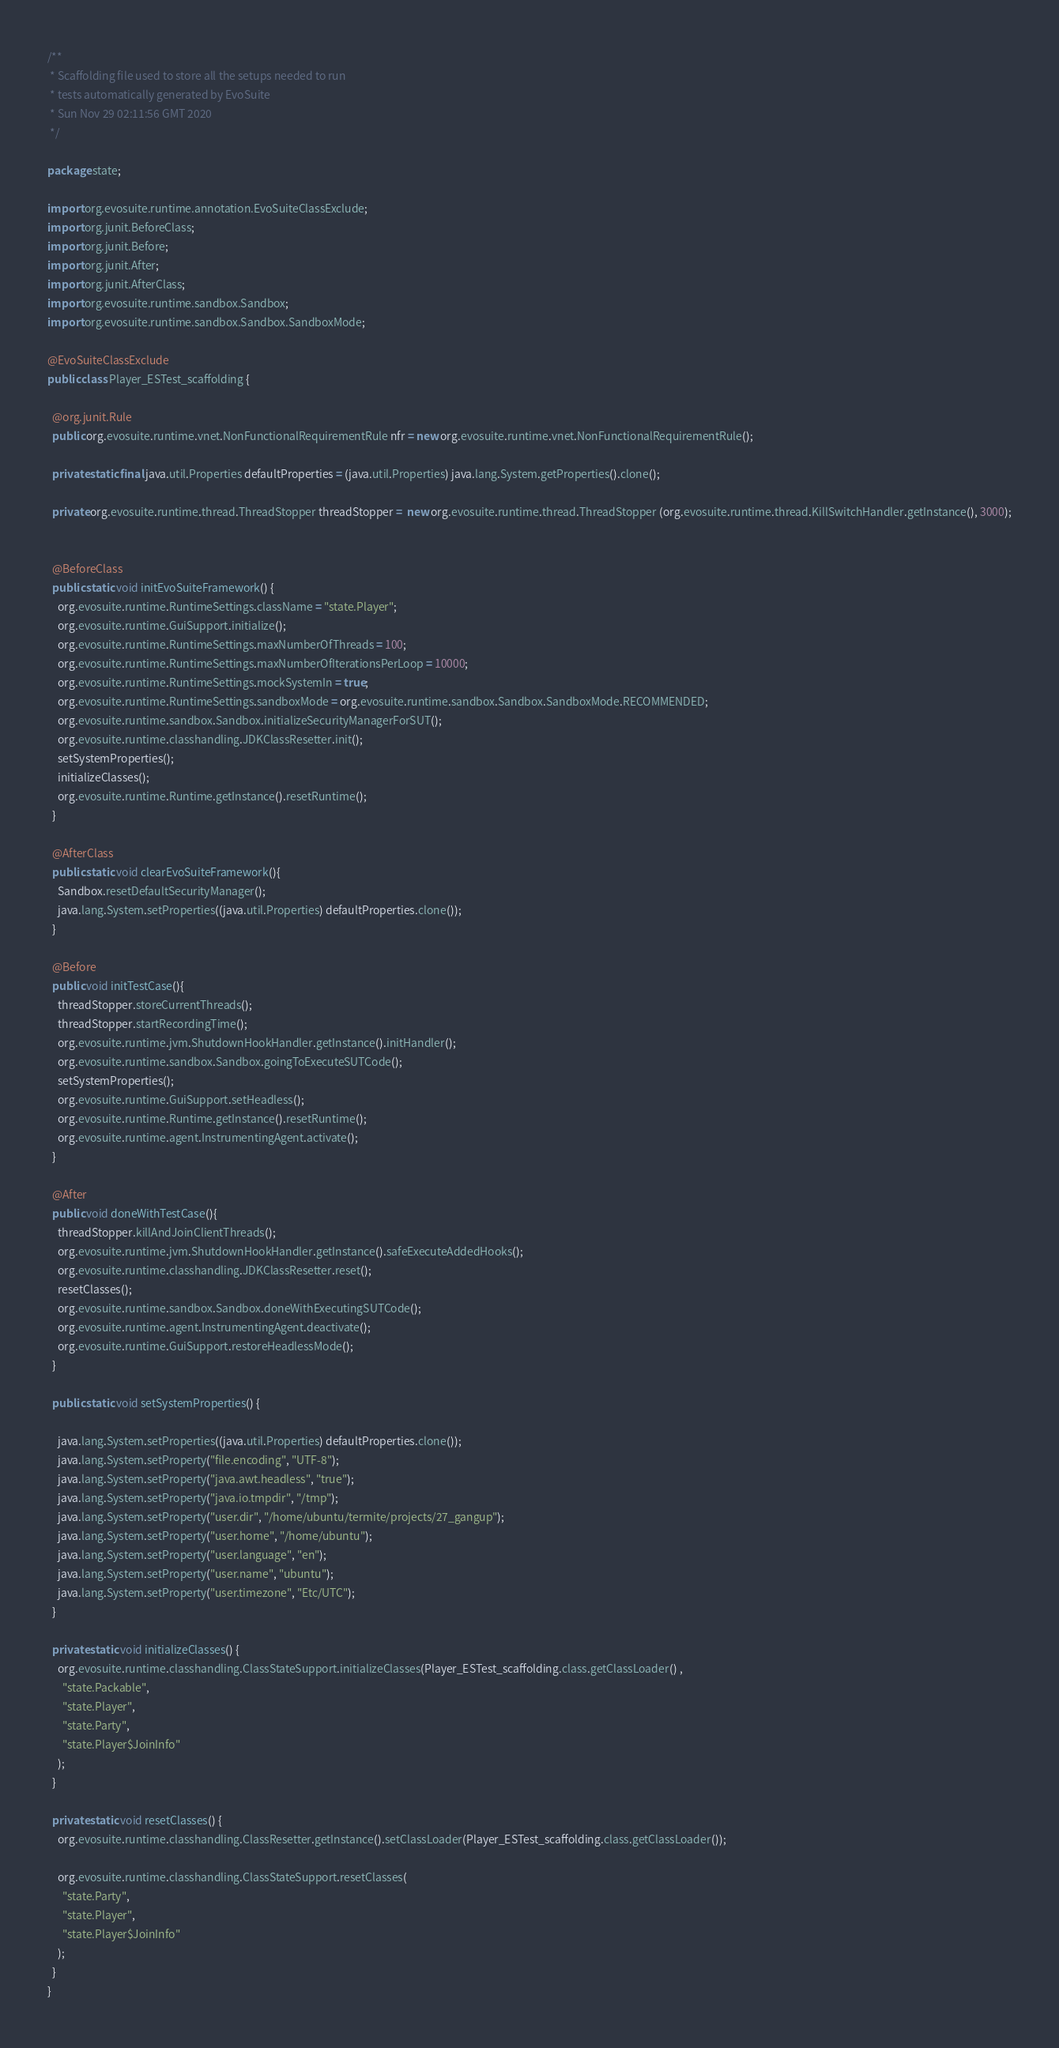Convert code to text. <code><loc_0><loc_0><loc_500><loc_500><_Java_>/**
 * Scaffolding file used to store all the setups needed to run 
 * tests automatically generated by EvoSuite
 * Sun Nov 29 02:11:56 GMT 2020
 */

package state;

import org.evosuite.runtime.annotation.EvoSuiteClassExclude;
import org.junit.BeforeClass;
import org.junit.Before;
import org.junit.After;
import org.junit.AfterClass;
import org.evosuite.runtime.sandbox.Sandbox;
import org.evosuite.runtime.sandbox.Sandbox.SandboxMode;

@EvoSuiteClassExclude
public class Player_ESTest_scaffolding {

  @org.junit.Rule 
  public org.evosuite.runtime.vnet.NonFunctionalRequirementRule nfr = new org.evosuite.runtime.vnet.NonFunctionalRequirementRule();

  private static final java.util.Properties defaultProperties = (java.util.Properties) java.lang.System.getProperties().clone(); 

  private org.evosuite.runtime.thread.ThreadStopper threadStopper =  new org.evosuite.runtime.thread.ThreadStopper (org.evosuite.runtime.thread.KillSwitchHandler.getInstance(), 3000);


  @BeforeClass 
  public static void initEvoSuiteFramework() { 
    org.evosuite.runtime.RuntimeSettings.className = "state.Player"; 
    org.evosuite.runtime.GuiSupport.initialize(); 
    org.evosuite.runtime.RuntimeSettings.maxNumberOfThreads = 100; 
    org.evosuite.runtime.RuntimeSettings.maxNumberOfIterationsPerLoop = 10000; 
    org.evosuite.runtime.RuntimeSettings.mockSystemIn = true; 
    org.evosuite.runtime.RuntimeSettings.sandboxMode = org.evosuite.runtime.sandbox.Sandbox.SandboxMode.RECOMMENDED; 
    org.evosuite.runtime.sandbox.Sandbox.initializeSecurityManagerForSUT(); 
    org.evosuite.runtime.classhandling.JDKClassResetter.init();
    setSystemProperties();
    initializeClasses();
    org.evosuite.runtime.Runtime.getInstance().resetRuntime(); 
  } 

  @AfterClass 
  public static void clearEvoSuiteFramework(){ 
    Sandbox.resetDefaultSecurityManager(); 
    java.lang.System.setProperties((java.util.Properties) defaultProperties.clone()); 
  } 

  @Before 
  public void initTestCase(){ 
    threadStopper.storeCurrentThreads();
    threadStopper.startRecordingTime();
    org.evosuite.runtime.jvm.ShutdownHookHandler.getInstance().initHandler(); 
    org.evosuite.runtime.sandbox.Sandbox.goingToExecuteSUTCode(); 
    setSystemProperties(); 
    org.evosuite.runtime.GuiSupport.setHeadless(); 
    org.evosuite.runtime.Runtime.getInstance().resetRuntime(); 
    org.evosuite.runtime.agent.InstrumentingAgent.activate(); 
  } 

  @After 
  public void doneWithTestCase(){ 
    threadStopper.killAndJoinClientThreads();
    org.evosuite.runtime.jvm.ShutdownHookHandler.getInstance().safeExecuteAddedHooks(); 
    org.evosuite.runtime.classhandling.JDKClassResetter.reset(); 
    resetClasses(); 
    org.evosuite.runtime.sandbox.Sandbox.doneWithExecutingSUTCode(); 
    org.evosuite.runtime.agent.InstrumentingAgent.deactivate(); 
    org.evosuite.runtime.GuiSupport.restoreHeadlessMode(); 
  } 

  public static void setSystemProperties() {
 
    java.lang.System.setProperties((java.util.Properties) defaultProperties.clone()); 
    java.lang.System.setProperty("file.encoding", "UTF-8"); 
    java.lang.System.setProperty("java.awt.headless", "true"); 
    java.lang.System.setProperty("java.io.tmpdir", "/tmp"); 
    java.lang.System.setProperty("user.dir", "/home/ubuntu/termite/projects/27_gangup"); 
    java.lang.System.setProperty("user.home", "/home/ubuntu"); 
    java.lang.System.setProperty("user.language", "en"); 
    java.lang.System.setProperty("user.name", "ubuntu"); 
    java.lang.System.setProperty("user.timezone", "Etc/UTC"); 
  }

  private static void initializeClasses() {
    org.evosuite.runtime.classhandling.ClassStateSupport.initializeClasses(Player_ESTest_scaffolding.class.getClassLoader() ,
      "state.Packable",
      "state.Player",
      "state.Party",
      "state.Player$JoinInfo"
    );
  } 

  private static void resetClasses() {
    org.evosuite.runtime.classhandling.ClassResetter.getInstance().setClassLoader(Player_ESTest_scaffolding.class.getClassLoader()); 

    org.evosuite.runtime.classhandling.ClassStateSupport.resetClasses(
      "state.Party",
      "state.Player",
      "state.Player$JoinInfo"
    );
  }
}
</code> 